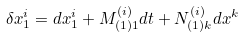Convert formula to latex. <formula><loc_0><loc_0><loc_500><loc_500>\delta x _ { 1 } ^ { i } = d x _ { 1 } ^ { i } + M _ { ( 1 ) 1 } ^ { ( i ) } d t + N _ { ( 1 ) k } ^ { ( i ) } d x ^ { k }</formula> 